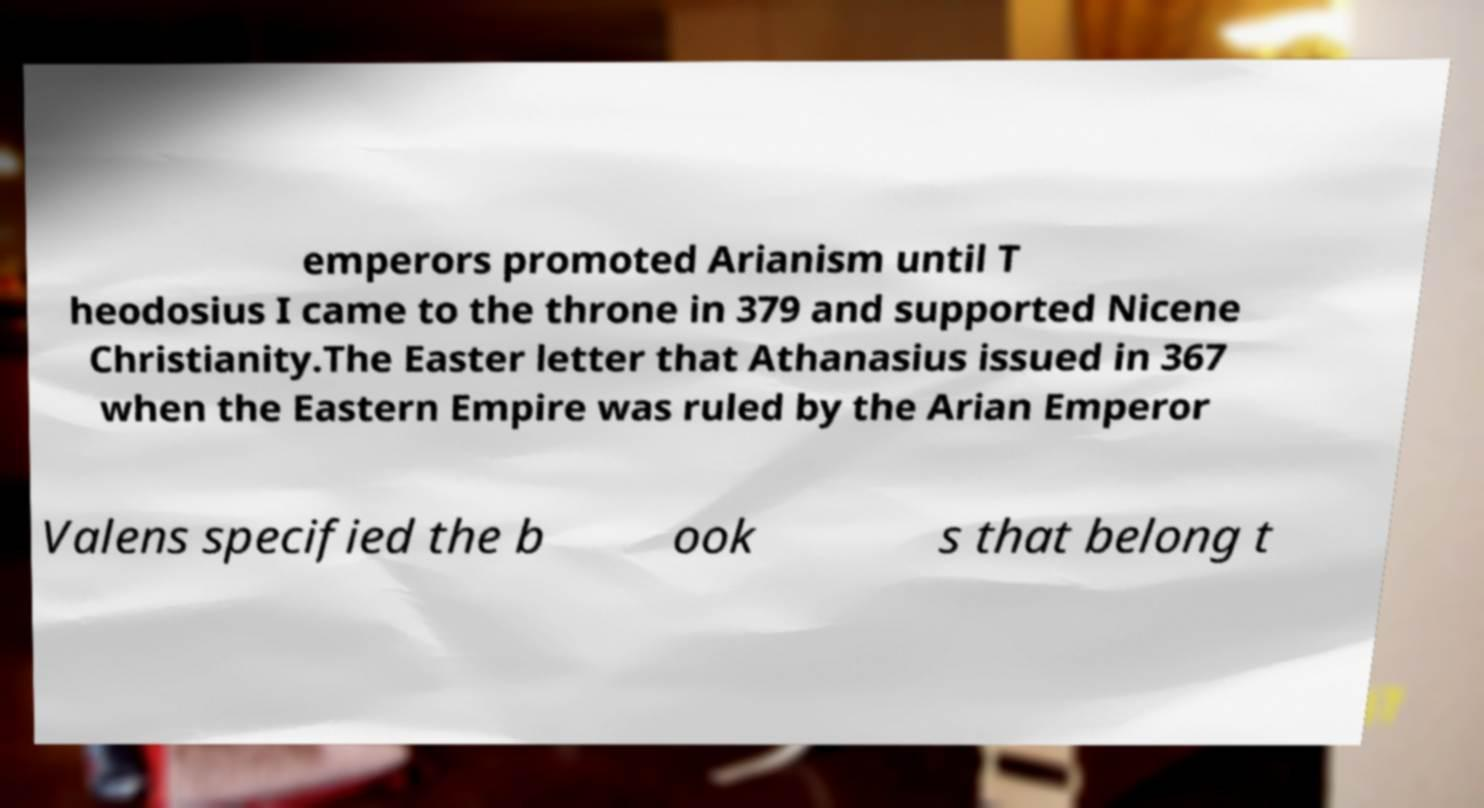Could you extract and type out the text from this image? emperors promoted Arianism until T heodosius I came to the throne in 379 and supported Nicene Christianity.The Easter letter that Athanasius issued in 367 when the Eastern Empire was ruled by the Arian Emperor Valens specified the b ook s that belong t 